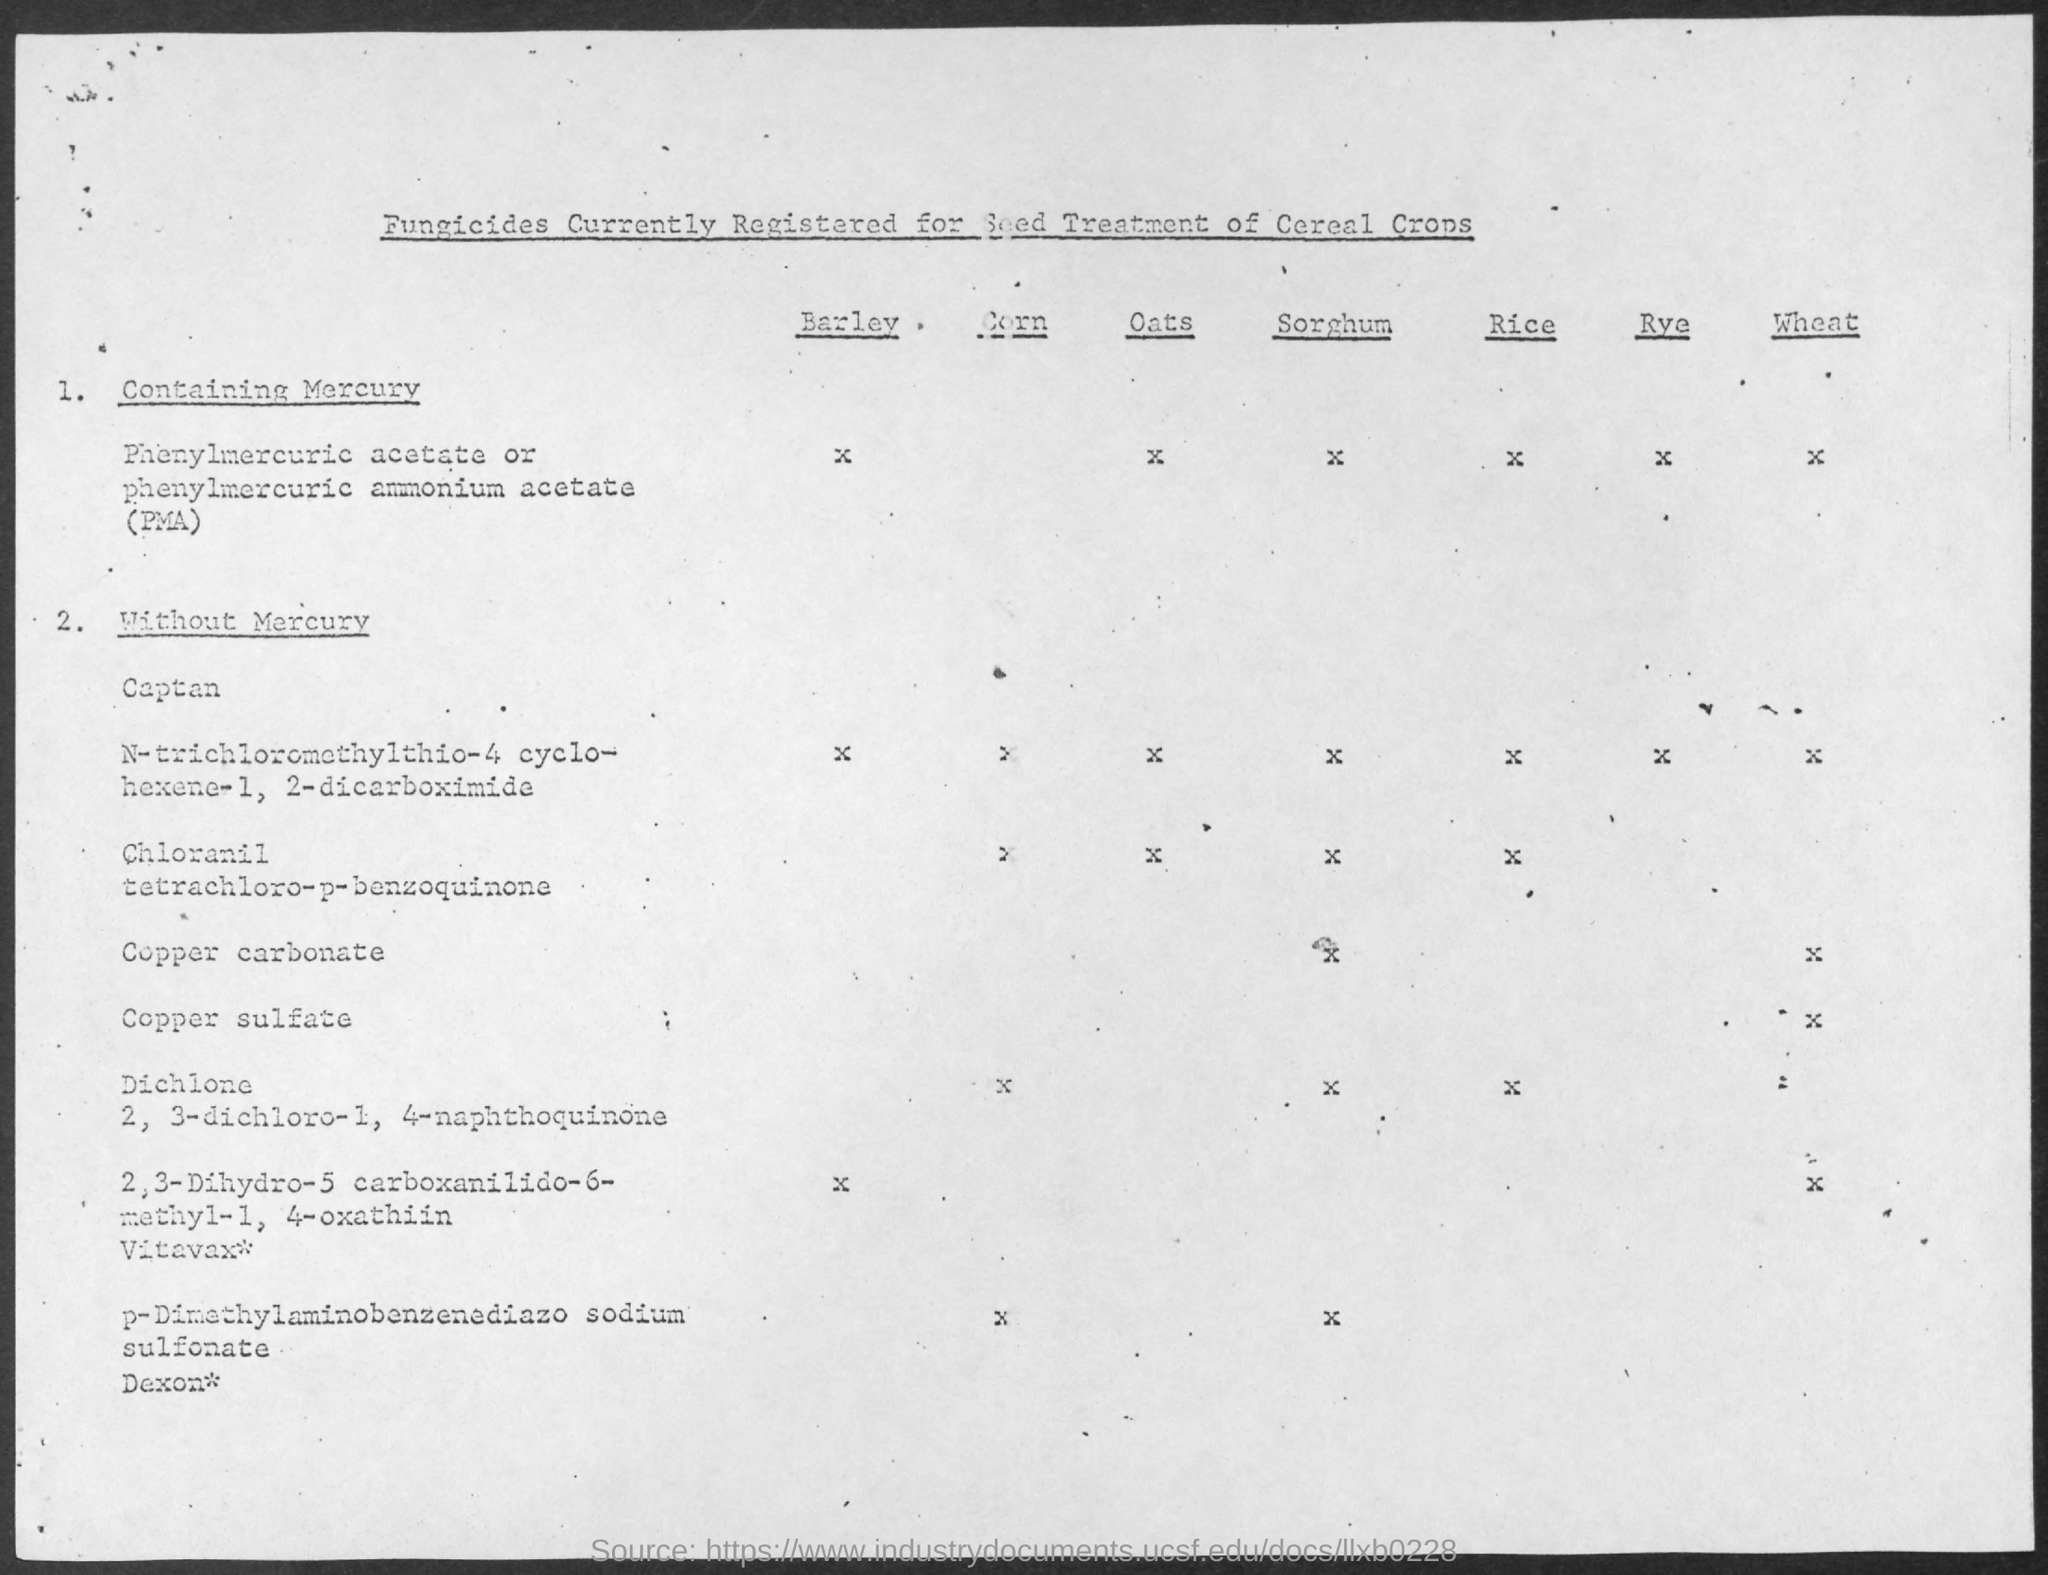Outline some significant characteristics in this image. The title of the document is 'Fungicides currently registered for seed treatment of cereal crops.' 